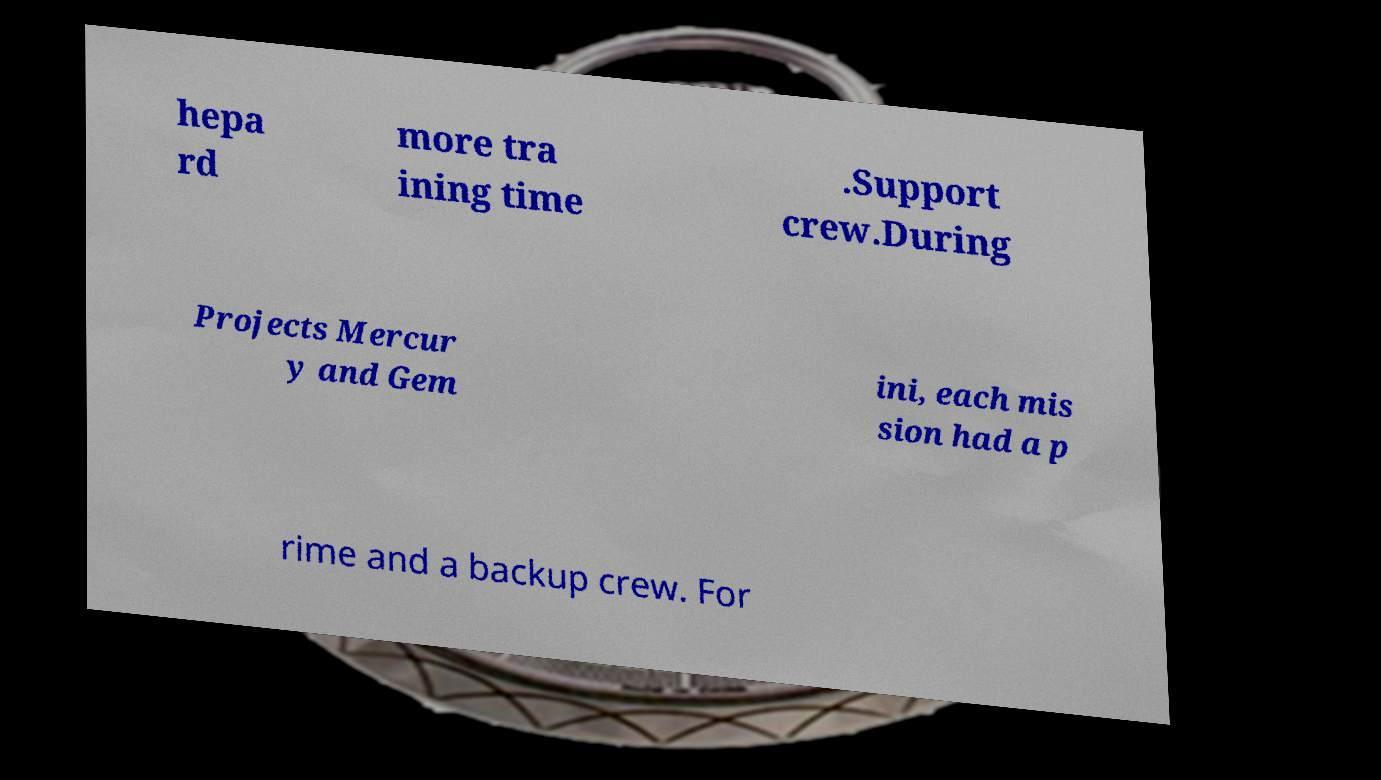Could you extract and type out the text from this image? hepa rd more tra ining time .Support crew.During Projects Mercur y and Gem ini, each mis sion had a p rime and a backup crew. For 